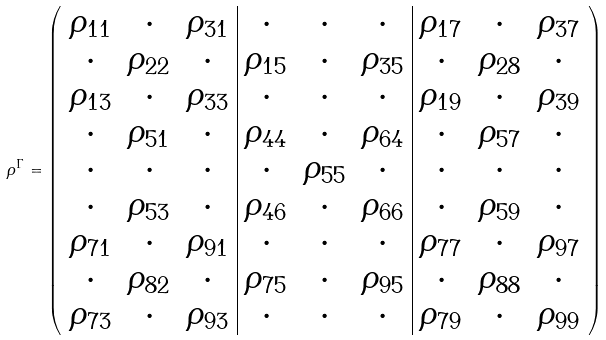<formula> <loc_0><loc_0><loc_500><loc_500>\rho ^ { \Gamma } = \left ( \begin{array} { c c c | c c c | c c c } \rho _ { 1 1 } & \cdot & \rho _ { 3 1 } & \cdot & \cdot & \cdot & \rho _ { 1 7 } & \cdot & \rho _ { 3 7 } \\ \cdot & \rho _ { 2 2 } & \cdot & \rho _ { 1 5 } & \cdot & \rho _ { 3 5 } & \cdot & \rho _ { 2 8 } & \cdot \\ \rho _ { 1 3 } & \cdot & \rho _ { 3 3 } & \cdot & \cdot & \cdot & \rho _ { 1 9 } & \cdot & \rho _ { 3 9 } \\ \cdot & \rho _ { 5 1 } & \cdot & \rho _ { 4 4 } & \cdot & \rho _ { 6 4 } & \cdot & \rho _ { 5 7 } & \cdot \\ \cdot & \cdot & \cdot & \cdot & \rho _ { 5 5 } & \cdot & \cdot & \cdot & \cdot \\ \cdot & \rho _ { 5 3 } & \cdot & \rho _ { 4 6 } & \cdot & \rho _ { 6 6 } & \cdot & \rho _ { 5 9 } & \cdot \\ \rho _ { 7 1 } & \cdot & \rho _ { 9 1 } & \cdot & \cdot & \cdot & \rho _ { 7 7 } & \cdot & \rho _ { 9 7 } \\ \cdot & \rho _ { 8 2 } & \cdot & \rho _ { 7 5 } & \cdot & \rho _ { 9 5 } & \cdot & \rho _ { 8 8 } & \cdot \\ \rho _ { 7 3 } & \cdot & \rho _ { 9 3 } & \cdot & \cdot & \cdot & \rho _ { 7 9 } & \cdot & \rho _ { 9 9 } \end{array} \right )</formula> 